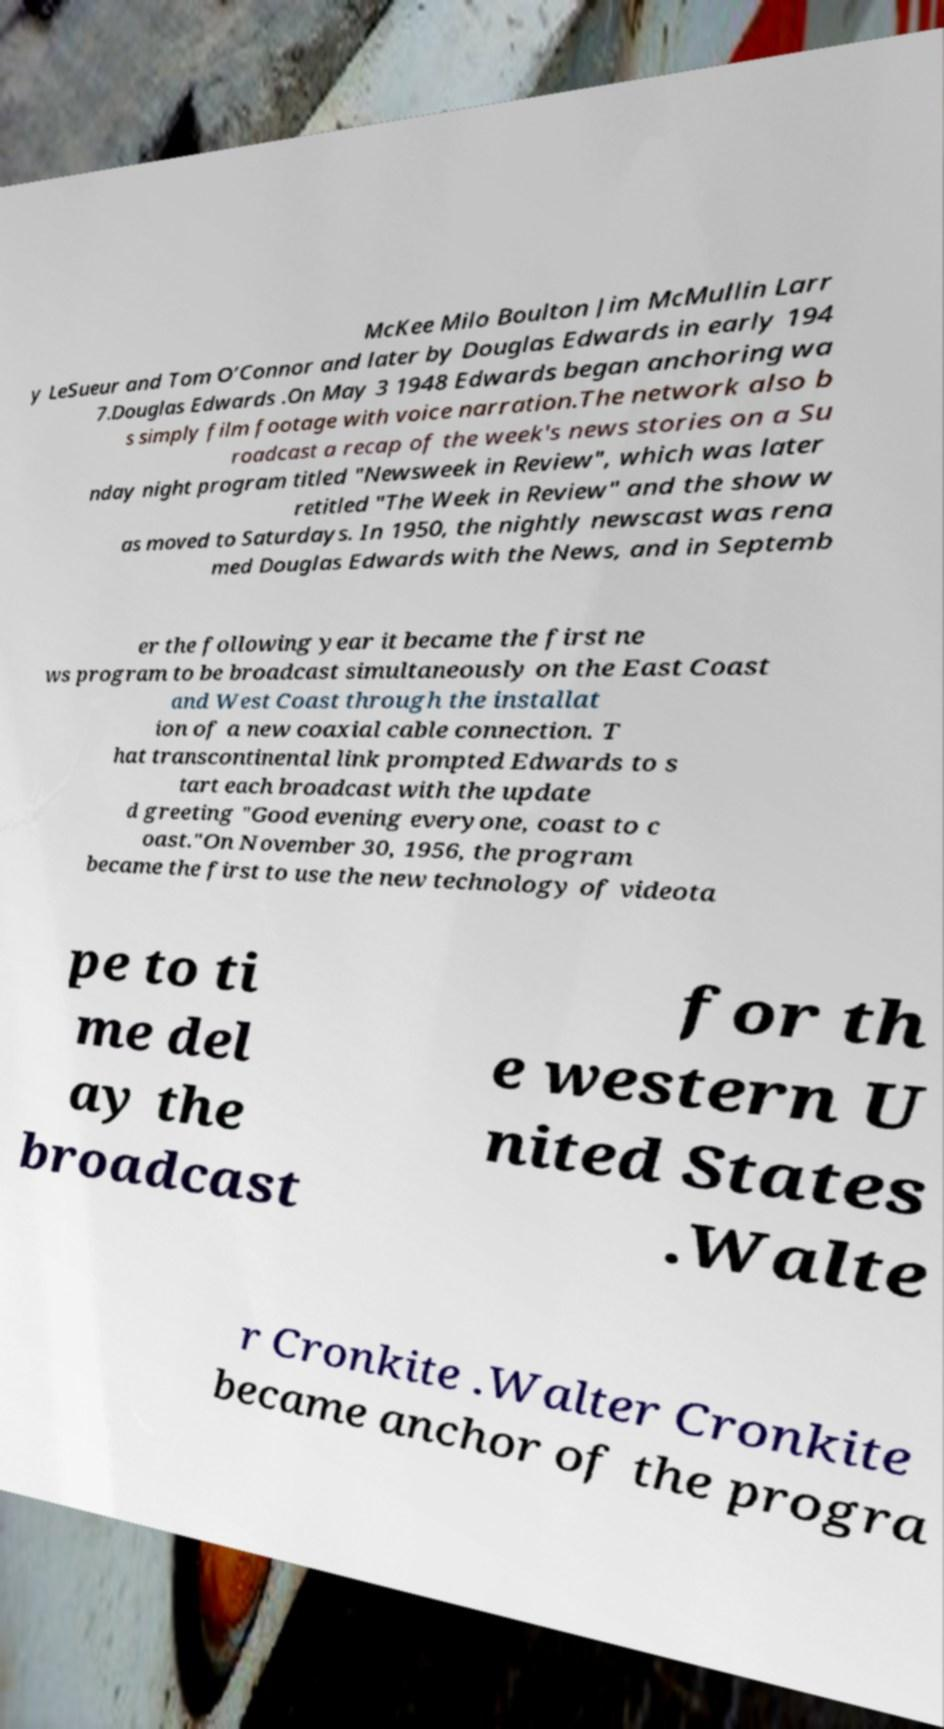Can you read and provide the text displayed in the image?This photo seems to have some interesting text. Can you extract and type it out for me? McKee Milo Boulton Jim McMullin Larr y LeSueur and Tom O’Connor and later by Douglas Edwards in early 194 7.Douglas Edwards .On May 3 1948 Edwards began anchoring wa s simply film footage with voice narration.The network also b roadcast a recap of the week's news stories on a Su nday night program titled "Newsweek in Review", which was later retitled "The Week in Review" and the show w as moved to Saturdays. In 1950, the nightly newscast was rena med Douglas Edwards with the News, and in Septemb er the following year it became the first ne ws program to be broadcast simultaneously on the East Coast and West Coast through the installat ion of a new coaxial cable connection. T hat transcontinental link prompted Edwards to s tart each broadcast with the update d greeting "Good evening everyone, coast to c oast."On November 30, 1956, the program became the first to use the new technology of videota pe to ti me del ay the broadcast for th e western U nited States .Walte r Cronkite .Walter Cronkite became anchor of the progra 